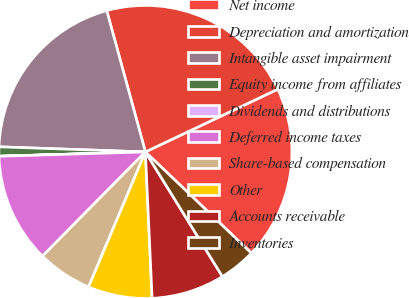<chart> <loc_0><loc_0><loc_500><loc_500><pie_chart><fcel>Net income<fcel>Depreciation and amortization<fcel>Intangible asset impairment<fcel>Equity income from affiliates<fcel>Dividends and distributions<fcel>Deferred income taxes<fcel>Share-based compensation<fcel>Other<fcel>Accounts receivable<fcel>Inventories<nl><fcel>19.18%<fcel>22.21%<fcel>20.19%<fcel>1.02%<fcel>0.01%<fcel>12.12%<fcel>6.06%<fcel>7.07%<fcel>8.08%<fcel>4.05%<nl></chart> 